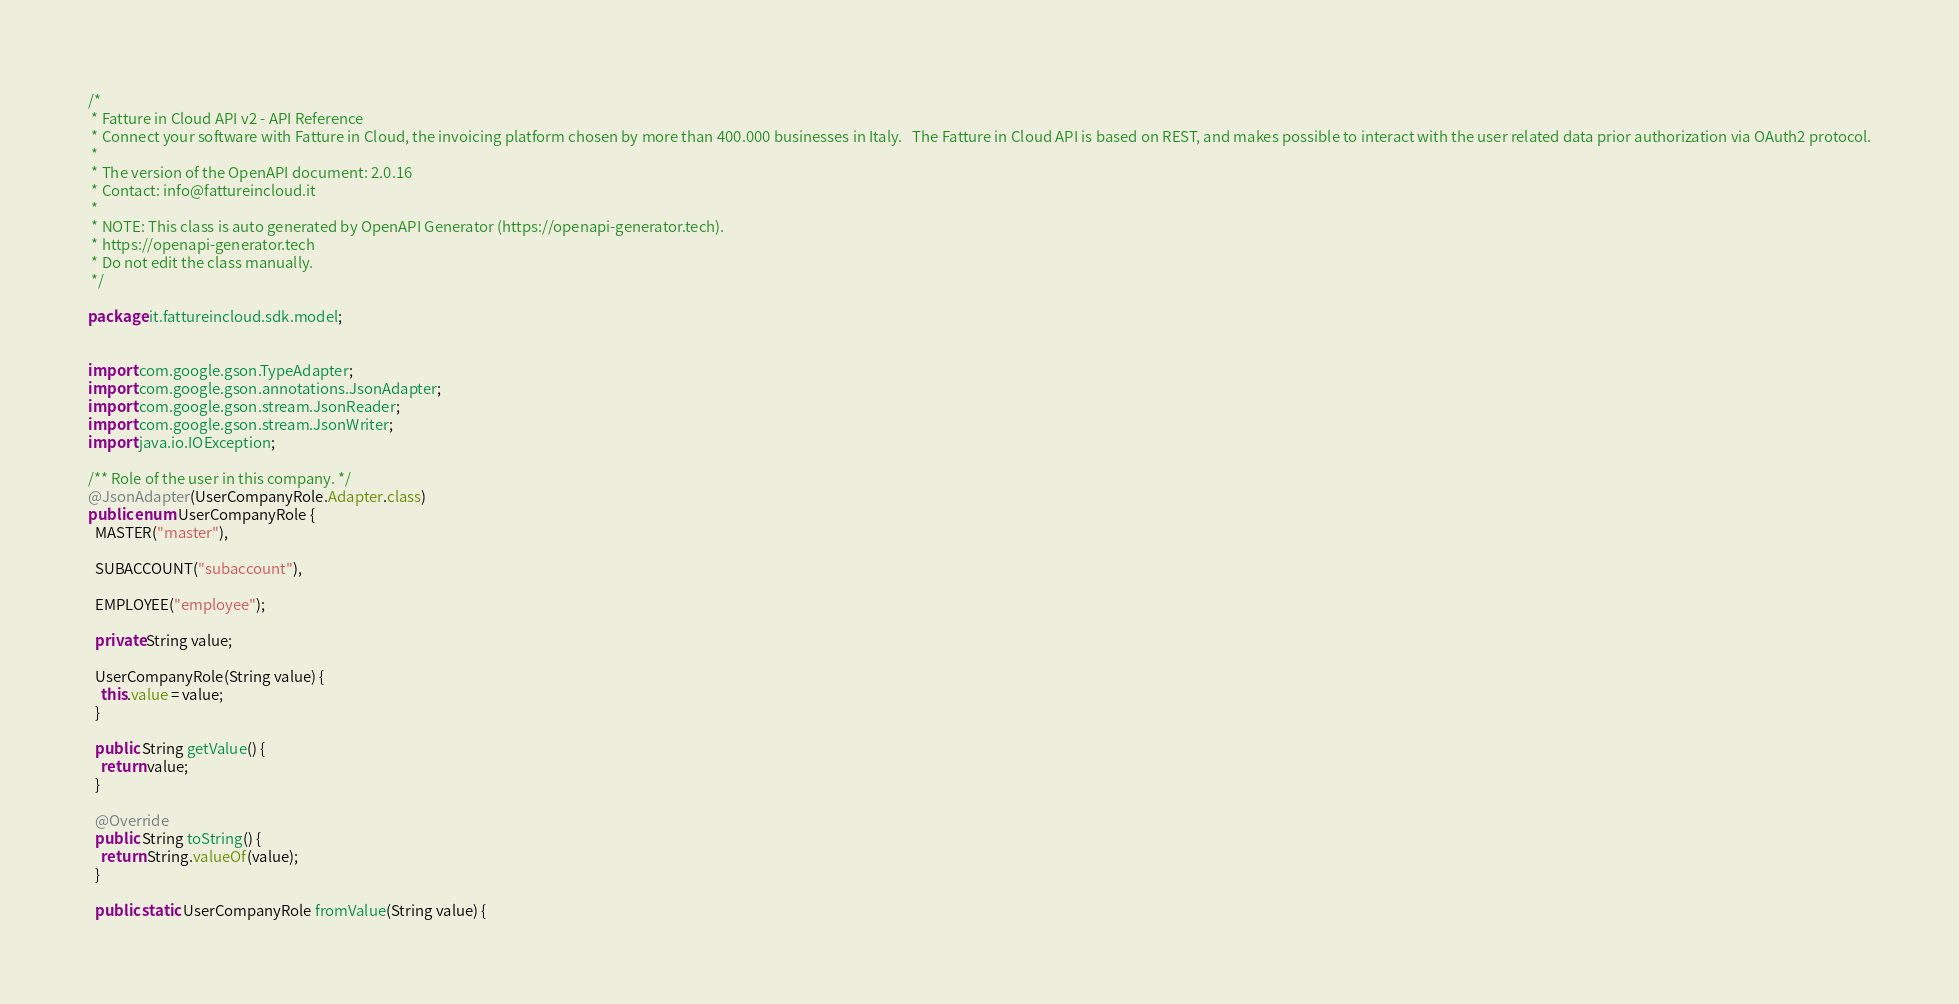<code> <loc_0><loc_0><loc_500><loc_500><_Java_>/*
 * Fatture in Cloud API v2 - API Reference
 * Connect your software with Fatture in Cloud, the invoicing platform chosen by more than 400.000 businesses in Italy.   The Fatture in Cloud API is based on REST, and makes possible to interact with the user related data prior authorization via OAuth2 protocol.
 *
 * The version of the OpenAPI document: 2.0.16
 * Contact: info@fattureincloud.it
 *
 * NOTE: This class is auto generated by OpenAPI Generator (https://openapi-generator.tech).
 * https://openapi-generator.tech
 * Do not edit the class manually.
 */

package it.fattureincloud.sdk.model;


import com.google.gson.TypeAdapter;
import com.google.gson.annotations.JsonAdapter;
import com.google.gson.stream.JsonReader;
import com.google.gson.stream.JsonWriter;
import java.io.IOException;

/** Role of the user in this company. */
@JsonAdapter(UserCompanyRole.Adapter.class)
public enum UserCompanyRole {
  MASTER("master"),

  SUBACCOUNT("subaccount"),

  EMPLOYEE("employee");

  private String value;

  UserCompanyRole(String value) {
    this.value = value;
  }

  public String getValue() {
    return value;
  }

  @Override
  public String toString() {
    return String.valueOf(value);
  }

  public static UserCompanyRole fromValue(String value) {</code> 